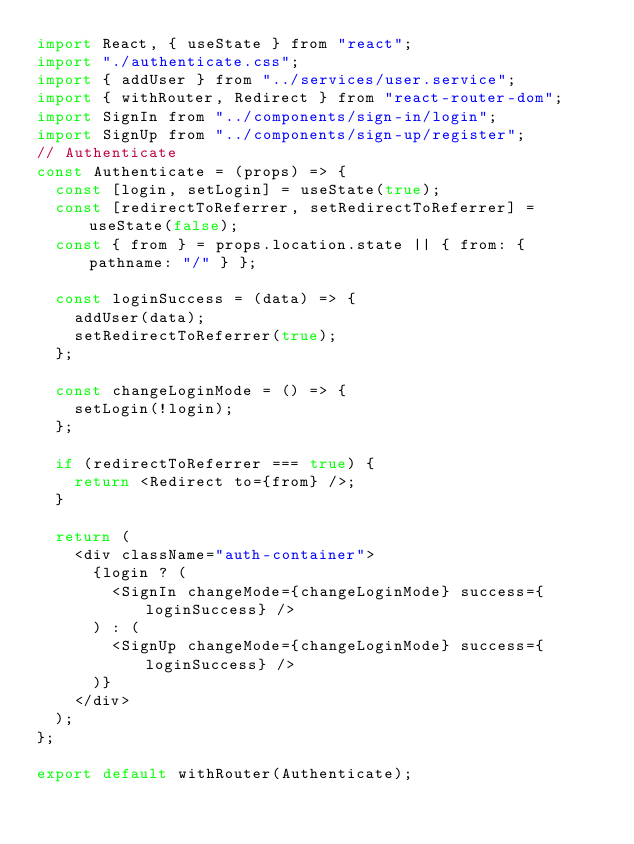Convert code to text. <code><loc_0><loc_0><loc_500><loc_500><_JavaScript_>import React, { useState } from "react";
import "./authenticate.css";
import { addUser } from "../services/user.service";
import { withRouter, Redirect } from "react-router-dom";
import SignIn from "../components/sign-in/login";
import SignUp from "../components/sign-up/register";
// Authenticate
const Authenticate = (props) => {
  const [login, setLogin] = useState(true);
  const [redirectToReferrer, setRedirectToReferrer] = useState(false);
  const { from } = props.location.state || { from: { pathname: "/" } };

  const loginSuccess = (data) => {
    addUser(data);
    setRedirectToReferrer(true);
  };

  const changeLoginMode = () => {
    setLogin(!login);
  };

  if (redirectToReferrer === true) {
    return <Redirect to={from} />;
  }

  return (
    <div className="auth-container">
      {login ? (
        <SignIn changeMode={changeLoginMode} success={loginSuccess} />
      ) : (
        <SignUp changeMode={changeLoginMode} success={loginSuccess} />
      )}
    </div>
  );
};

export default withRouter(Authenticate);
</code> 